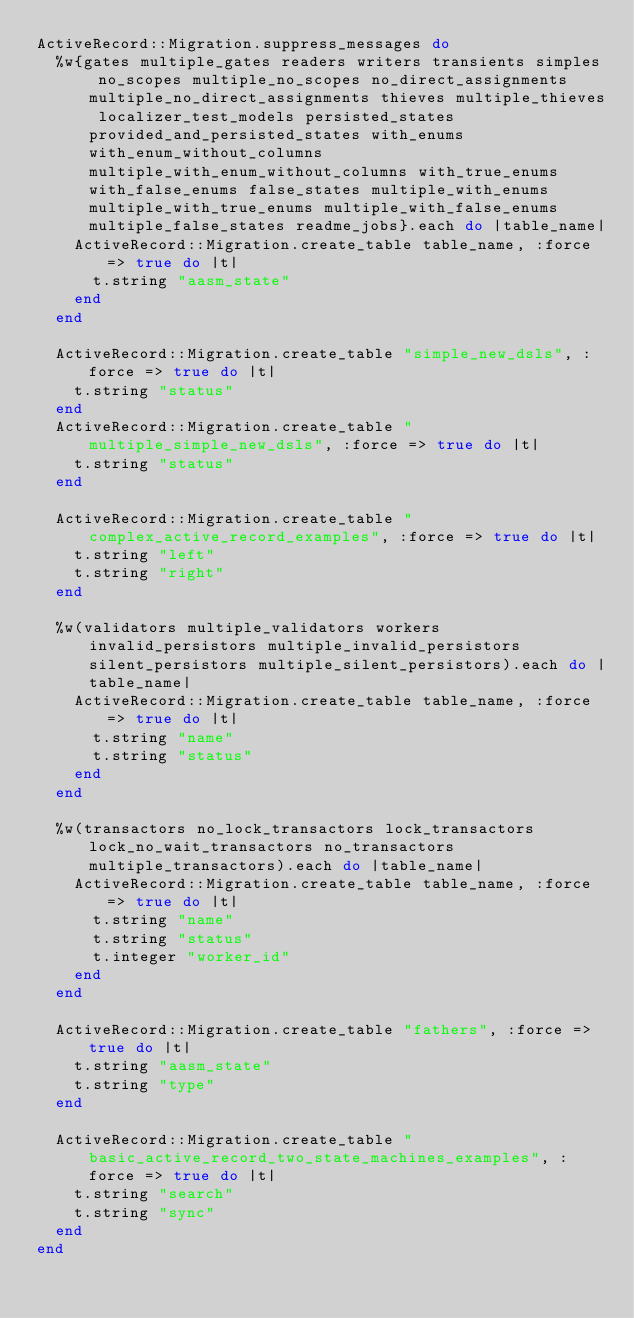<code> <loc_0><loc_0><loc_500><loc_500><_Ruby_>ActiveRecord::Migration.suppress_messages do
  %w{gates multiple_gates readers writers transients simples no_scopes multiple_no_scopes no_direct_assignments multiple_no_direct_assignments thieves multiple_thieves localizer_test_models persisted_states provided_and_persisted_states with_enums with_enum_without_columns multiple_with_enum_without_columns with_true_enums with_false_enums false_states multiple_with_enums multiple_with_true_enums multiple_with_false_enums multiple_false_states readme_jobs}.each do |table_name|
    ActiveRecord::Migration.create_table table_name, :force => true do |t|
      t.string "aasm_state"
    end
  end

  ActiveRecord::Migration.create_table "simple_new_dsls", :force => true do |t|
    t.string "status"
  end
  ActiveRecord::Migration.create_table "multiple_simple_new_dsls", :force => true do |t|
    t.string "status"
  end

  ActiveRecord::Migration.create_table "complex_active_record_examples", :force => true do |t|
    t.string "left"
    t.string "right"
  end

  %w(validators multiple_validators workers invalid_persistors multiple_invalid_persistors silent_persistors multiple_silent_persistors).each do |table_name|
    ActiveRecord::Migration.create_table table_name, :force => true do |t|
      t.string "name"
      t.string "status"
    end
  end

  %w(transactors no_lock_transactors lock_transactors lock_no_wait_transactors no_transactors multiple_transactors).each do |table_name|
    ActiveRecord::Migration.create_table table_name, :force => true do |t|
      t.string "name"
      t.string "status"
      t.integer "worker_id"
    end
  end

  ActiveRecord::Migration.create_table "fathers", :force => true do |t|
    t.string "aasm_state"
    t.string "type"
  end

  ActiveRecord::Migration.create_table "basic_active_record_two_state_machines_examples", :force => true do |t|
    t.string "search"
    t.string "sync"
  end
end
</code> 